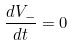<formula> <loc_0><loc_0><loc_500><loc_500>\frac { d V _ { - } } { d t } = 0</formula> 